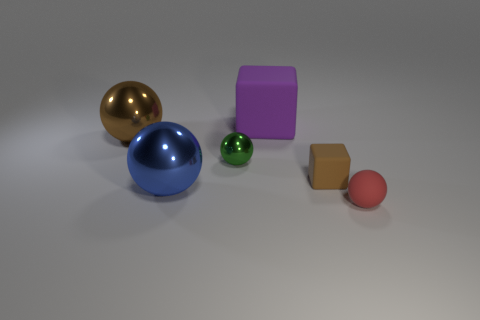Subtract 1 balls. How many balls are left? 3 Add 4 red matte objects. How many objects exist? 10 Subtract all balls. How many objects are left? 2 Add 6 purple things. How many purple things are left? 7 Add 3 large gray objects. How many large gray objects exist? 3 Subtract 0 blue cylinders. How many objects are left? 6 Subtract all spheres. Subtract all tiny rubber objects. How many objects are left? 0 